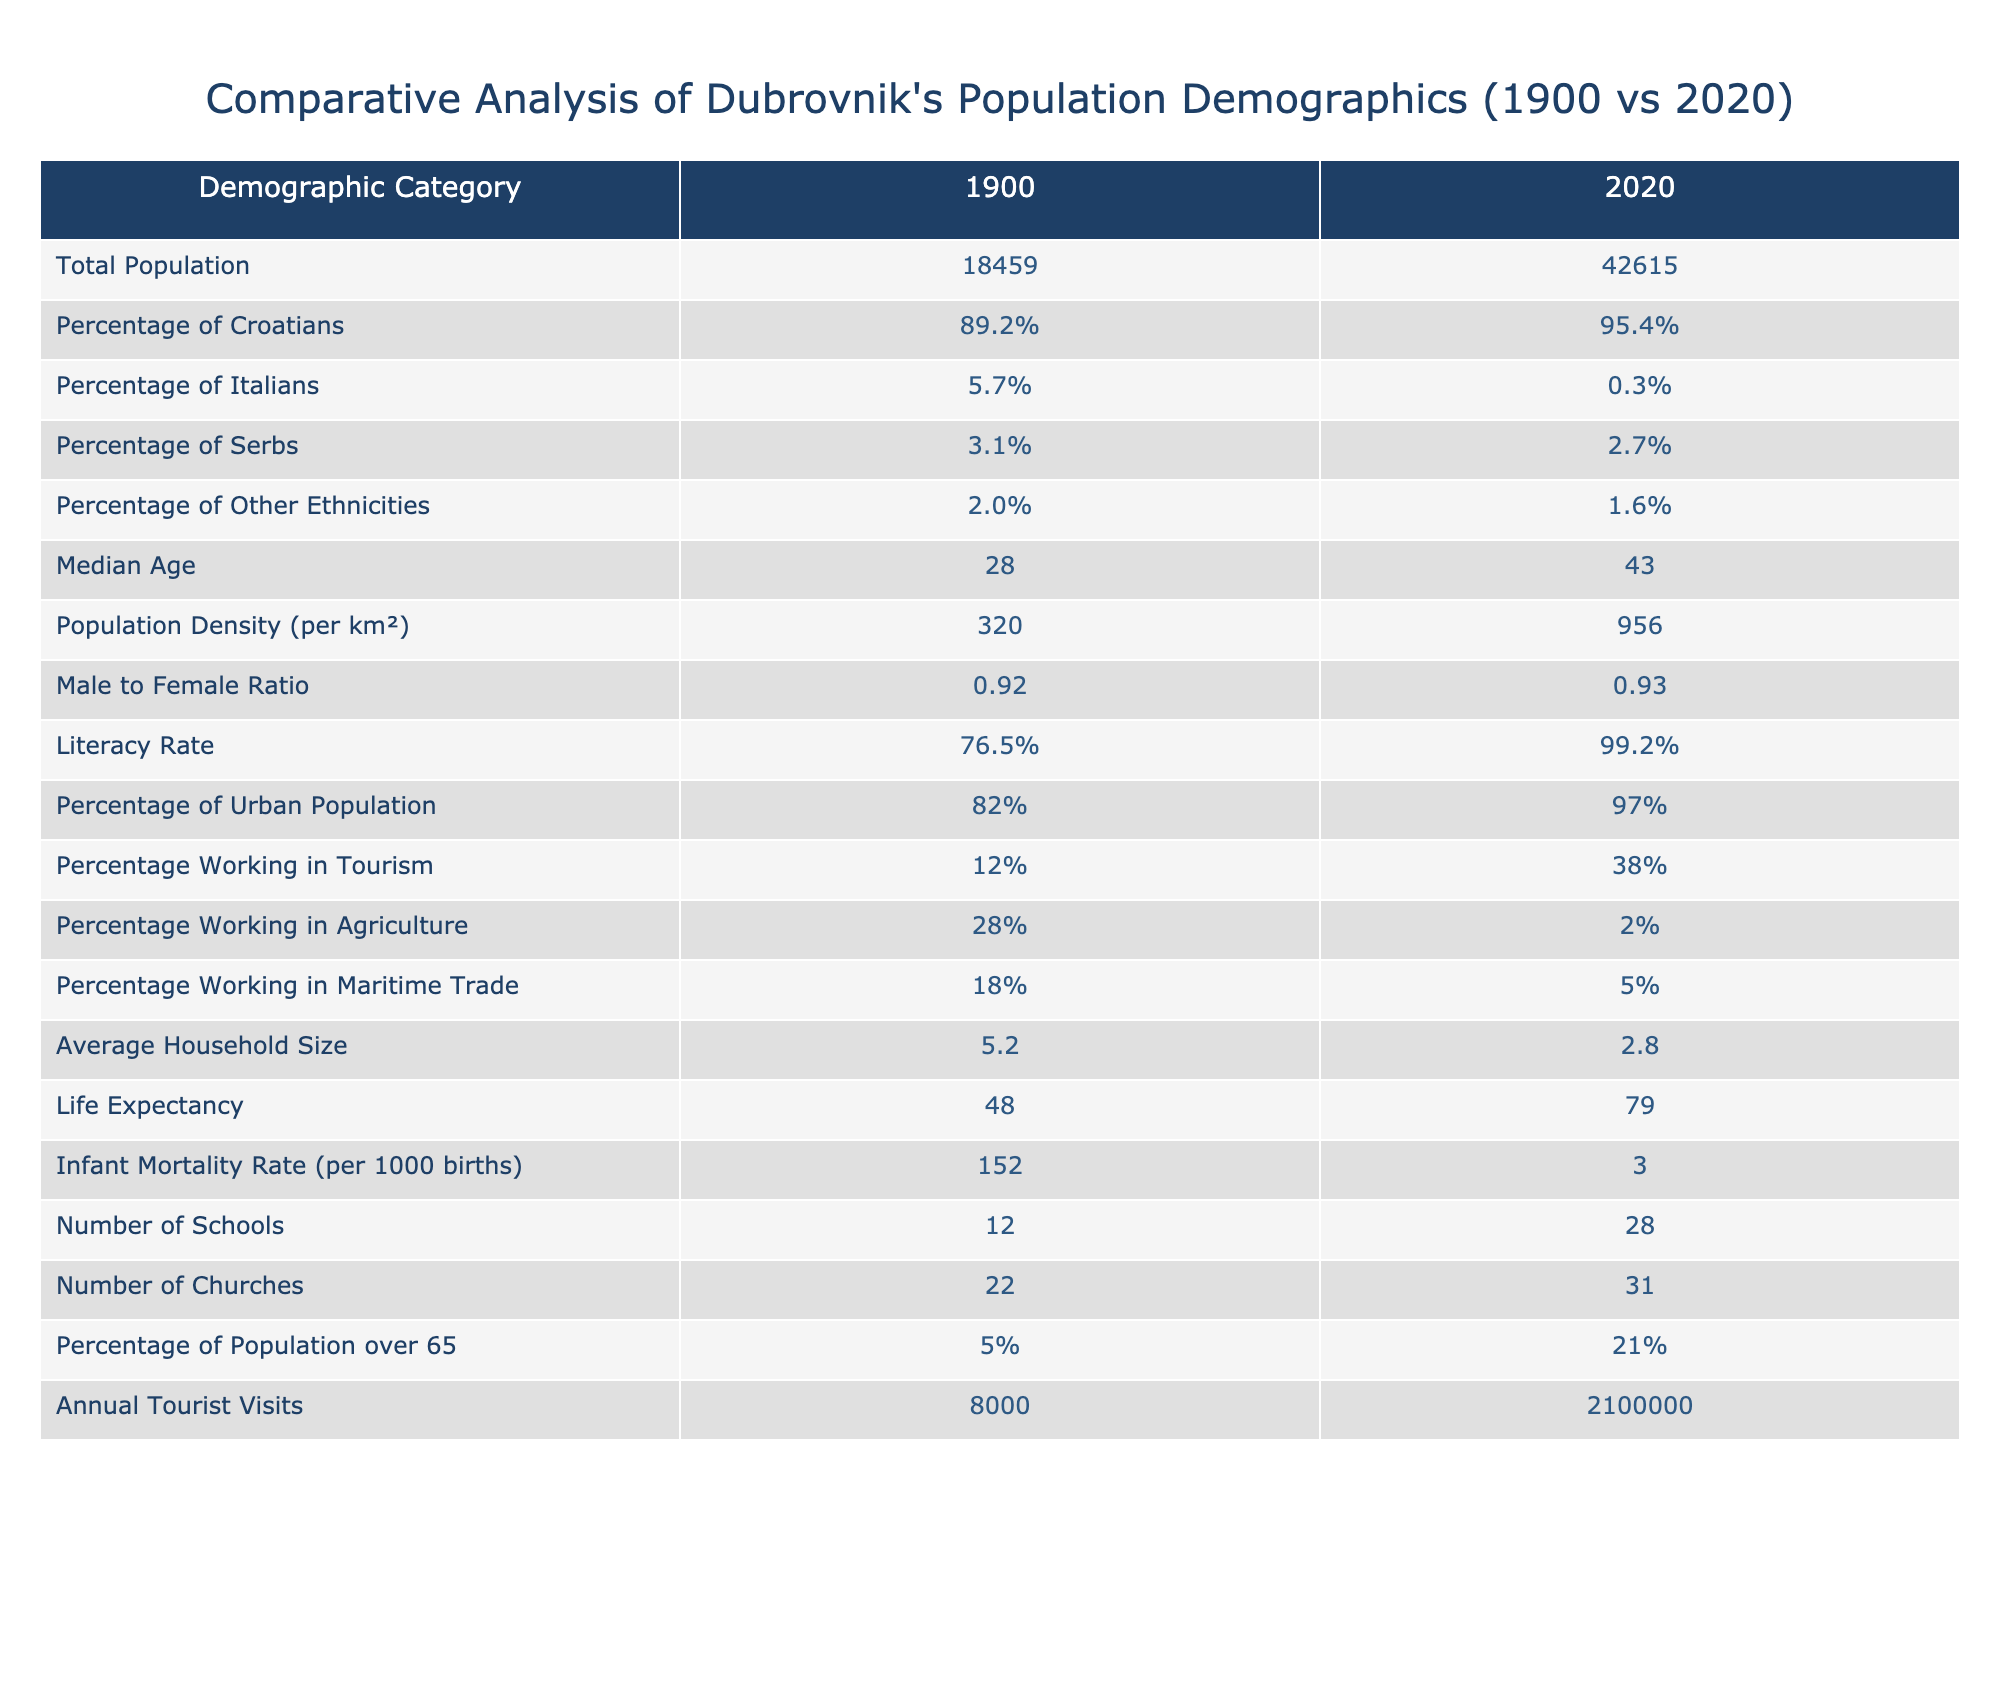What was the total population of Dubrovnik in 1900? The table states that the total population of Dubrovnik in 1900 was recorded as 18,459.
Answer: 18459 What was the life expectancy in 2020? According to the table, life expectancy in 2020 is shown as 79 years.
Answer: 79 How many more schools were there in 2020 compared to 1900? In 2020, there were 28 schools, and in 1900 there were 12 schools. The difference is 28 - 12 = 16.
Answer: 16 What percentage of the population worked in agriculture in 1900? The table shows that 28% of the population worked in agriculture in 1900.
Answer: 28% Is the literacy rate in 2020 higher than in 1900? The literacy rate in 2020 is 99.2%, compared to 76.5% in 1900, which confirms that it is higher.
Answer: Yes What is the change in the percentage of Italians from 1900 to 2020? The percentage of Italians decreased from 5.7% in 1900 to 0.3% in 2020, resulting in a change of 5.7% - 0.3% = 5.4%.
Answer: 5.4% What was the percentage increase in annual tourist visits from 1900 to 2020? Annual tourist visits increased from 8,000 in 1900 to 2,100,000 in 2020. The increase is 2,100,000 - 8,000 = 2,092,000, which is a percentage increase of (2,092,000 / 8,000) * 100 = 26,150%.
Answer: 26150% Did the percentage of the urban population increase or decrease from 1900 to 2020? The percentage of the urban population increased from 82% in 1900 to 97% in 2020, indicating an increase.
Answer: Increased What is the ratio of male to female populations in 1900 compared to 2020? In 1900, the ratio was 0.92, slightly lower than in 2020 where it is 0.93, indicating a slight increase in the ratio.
Answer: 0.92 vs 0.93 How does the median age in 2020 compare to that in 1900? The median age increased from 28 in 1900 to 43 in 2020, showing a difference of 43 - 28 = 15 years.
Answer: Increased by 15 years 